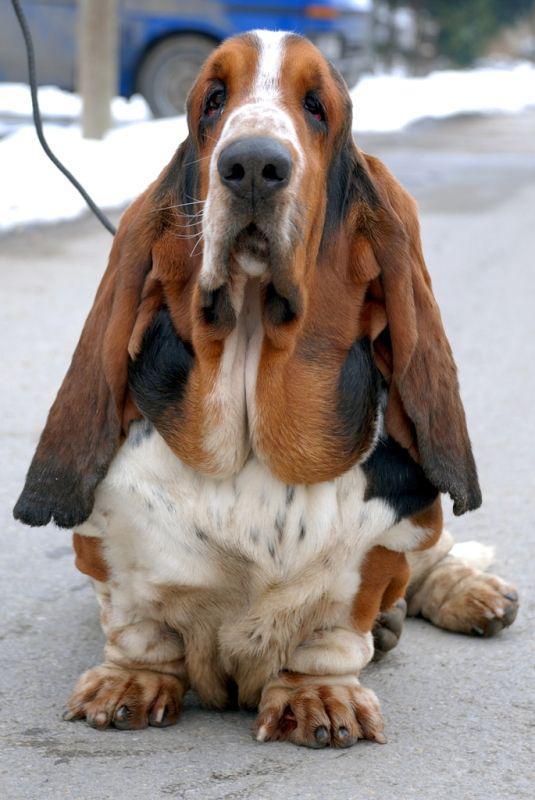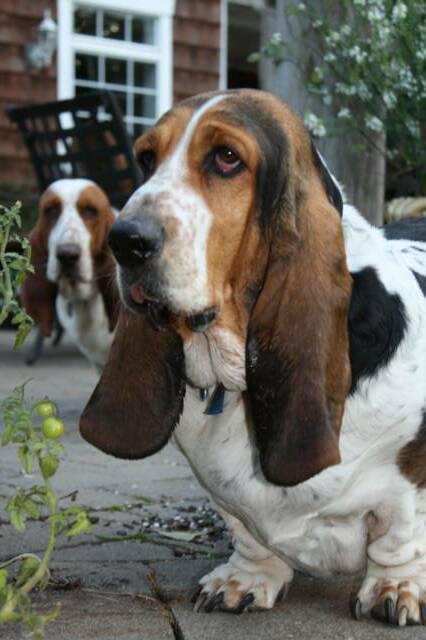The first image is the image on the left, the second image is the image on the right. Given the left and right images, does the statement "There are three dogs." hold true? Answer yes or no. Yes. 